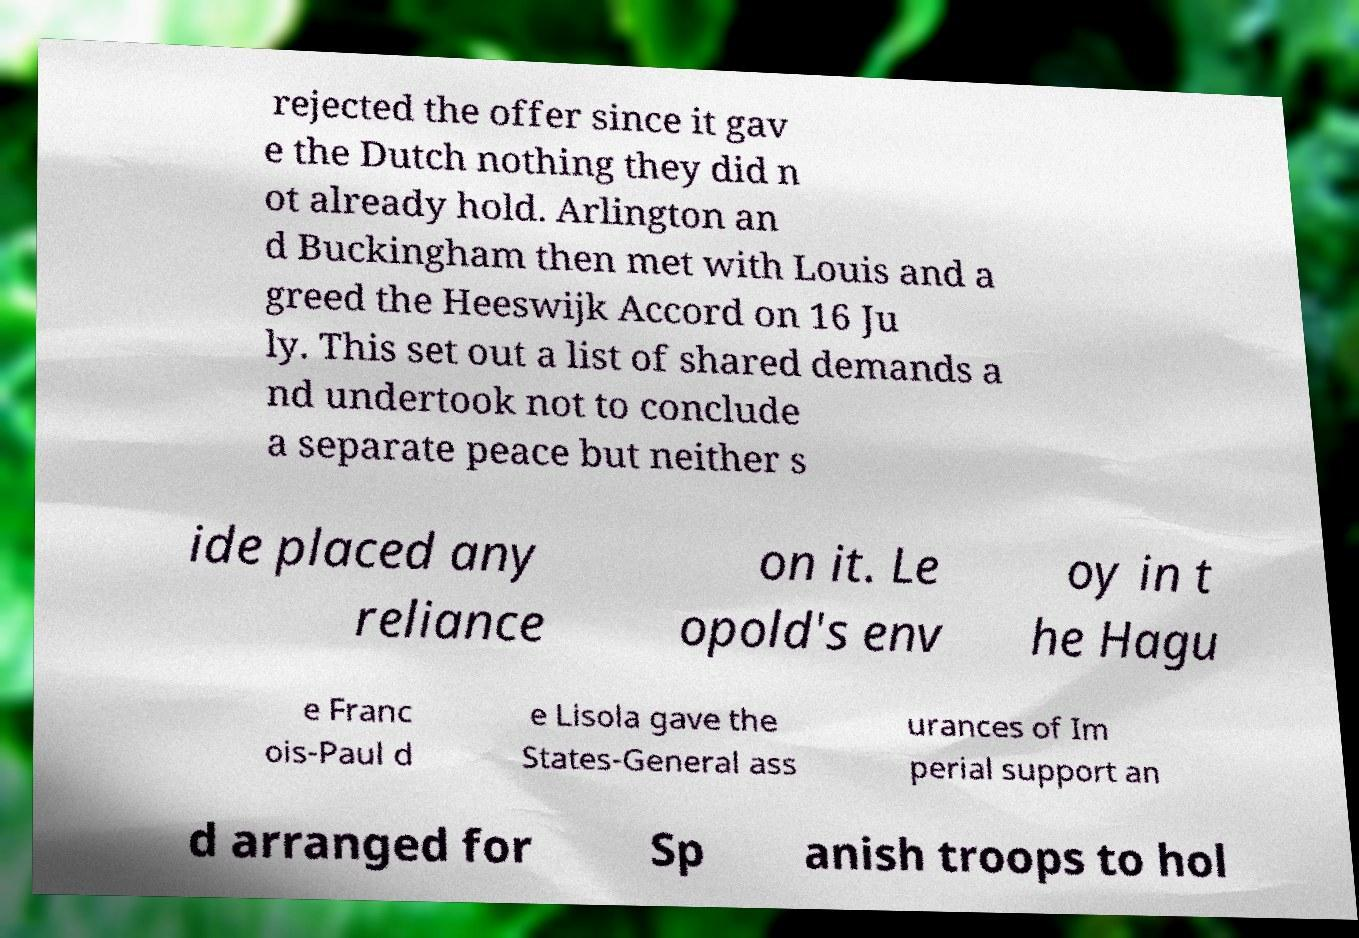Can you read and provide the text displayed in the image?This photo seems to have some interesting text. Can you extract and type it out for me? rejected the offer since it gav e the Dutch nothing they did n ot already hold. Arlington an d Buckingham then met with Louis and a greed the Heeswijk Accord on 16 Ju ly. This set out a list of shared demands a nd undertook not to conclude a separate peace but neither s ide placed any reliance on it. Le opold's env oy in t he Hagu e Franc ois-Paul d e Lisola gave the States-General ass urances of Im perial support an d arranged for Sp anish troops to hol 